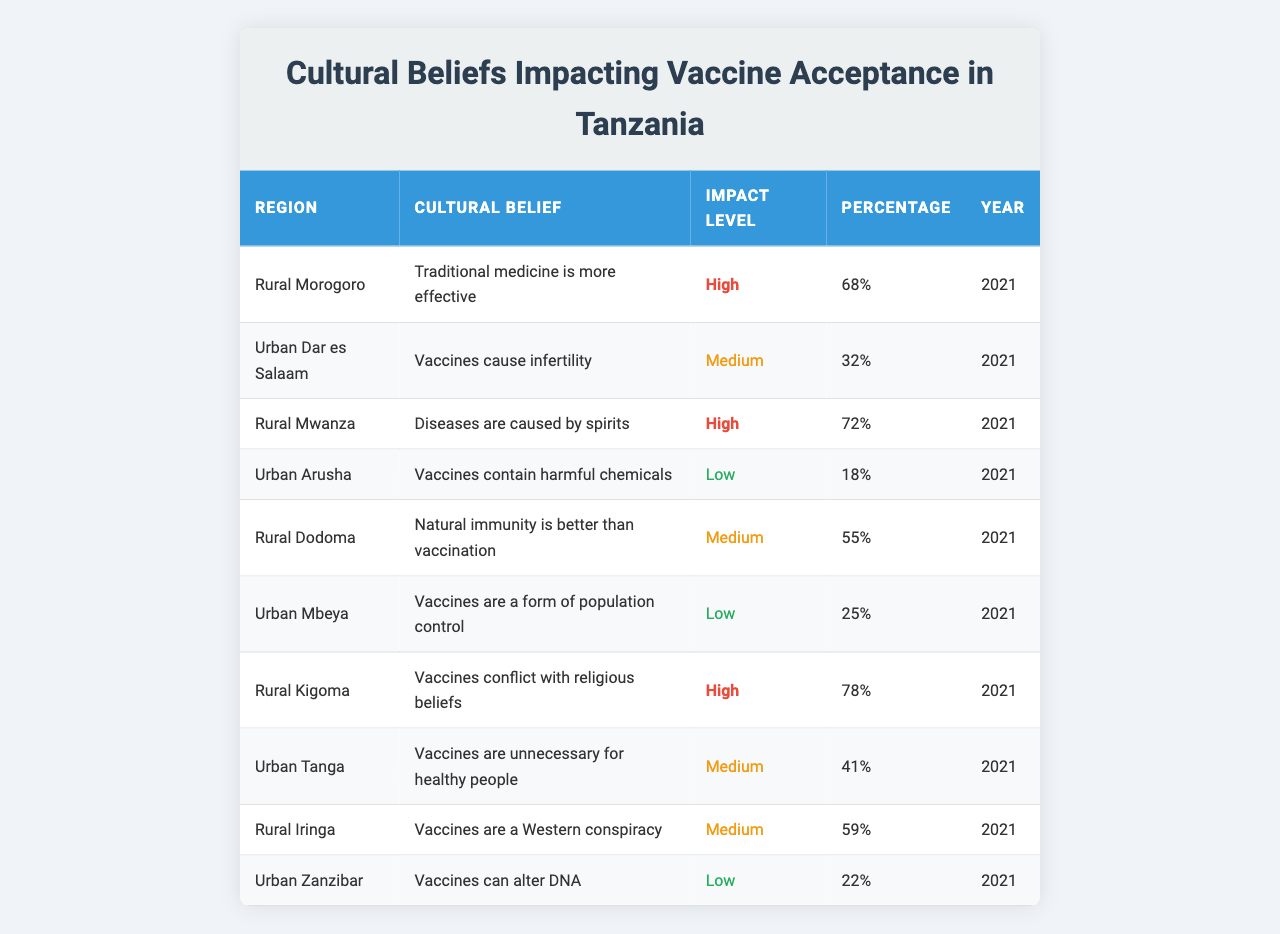What is the highest percentage of belief impacting vaccine acceptance observed in rural areas? In the table, the highest percentage in rural areas is found in Rural Kigoma, where 78% believe that vaccines conflict with religious beliefs.
Answer: 78% Which urban region has the lowest percentage of belief impacting vaccine acceptance? Looking at the table, Urban Arusha shows the lowest percentage at only 18% believing that vaccines contain harmful chemicals.
Answer: 18% What percentage of rural Mwanza believes diseases are caused by spirits? The table states that in Rural Mwanza, 72% hold the belief that diseases are caused by spirits.
Answer: 72% Is there any urban area where more than 30% of the population believes that vaccines cause infertility? The table indicates that Urban Dar es Salaam has 32% of its population believing vaccines cause infertility, so the answer is yes.
Answer: Yes How many beliefs impacting vaccine acceptance in urban areas are rated as high? The table shows that there are no beliefs in urban areas rated as high; all are either medium or low.
Answer: 0 What is the average percentage of beliefs related to vaccine acceptance in Rural areas? To find the average, we sum the percentages from the rural regions: (68 + 72 + 55 + 78 + 59) = 332. There are 5 rural regions, therefore the average is 332/5 = 66.4.
Answer: 66.4% Which urban area has a medium impact level, and what is the percentage associated with it? The medium impact level beliefs in Urban Tanga and Urban Dar es Salaam have percentages of 41% and 32%, respectively; Urban Tanga is the one with a higher percentage.
Answer: 41% in Urban Tanga Are traditional medicine beliefs impacting vaccine acceptance higher in rural Morogoro than any urban beliefs? In rural Morogoro, the belief that traditional medicine is more effective has a 68% impact level, which is higher than any urban belief listed, as the highest urban belief is 32%.
Answer: Yes What is the difference in percentage between the highest rural belief and the highest urban belief observed? The highest rural belief is 78% (Rural Kigoma), while the highest urban belief is 32% (Urban Dar es Salaam). The difference is 78 - 32 = 46%.
Answer: 46% 